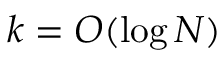Convert formula to latex. <formula><loc_0><loc_0><loc_500><loc_500>k = O ( \log N )</formula> 